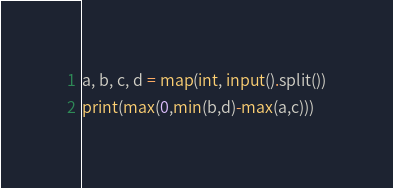Convert code to text. <code><loc_0><loc_0><loc_500><loc_500><_Python_>a, b, c, d = map(int, input().split())
print(max(0,min(b,d)-max(a,c)))</code> 